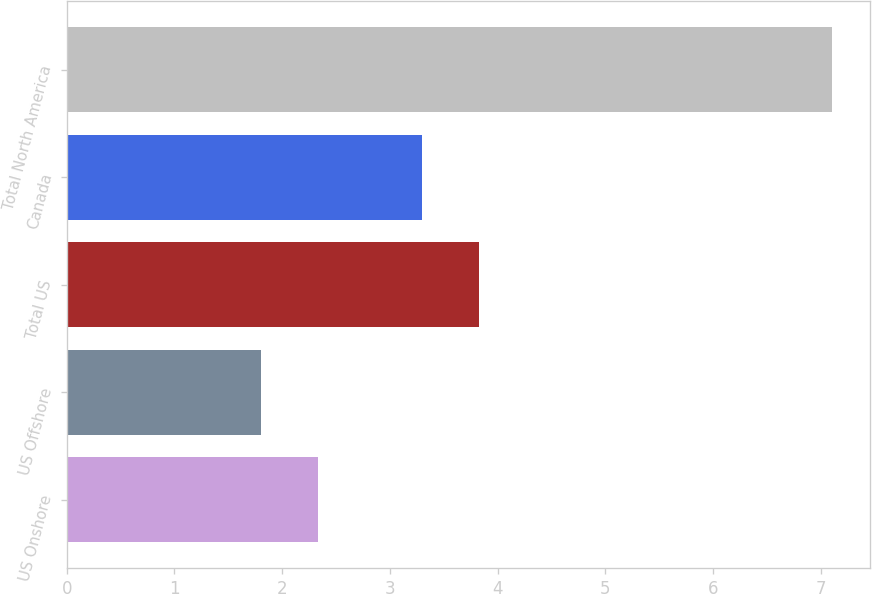Convert chart. <chart><loc_0><loc_0><loc_500><loc_500><bar_chart><fcel>US Onshore<fcel>US Offshore<fcel>Total US<fcel>Canada<fcel>Total North America<nl><fcel>2.33<fcel>1.8<fcel>3.83<fcel>3.3<fcel>7.1<nl></chart> 